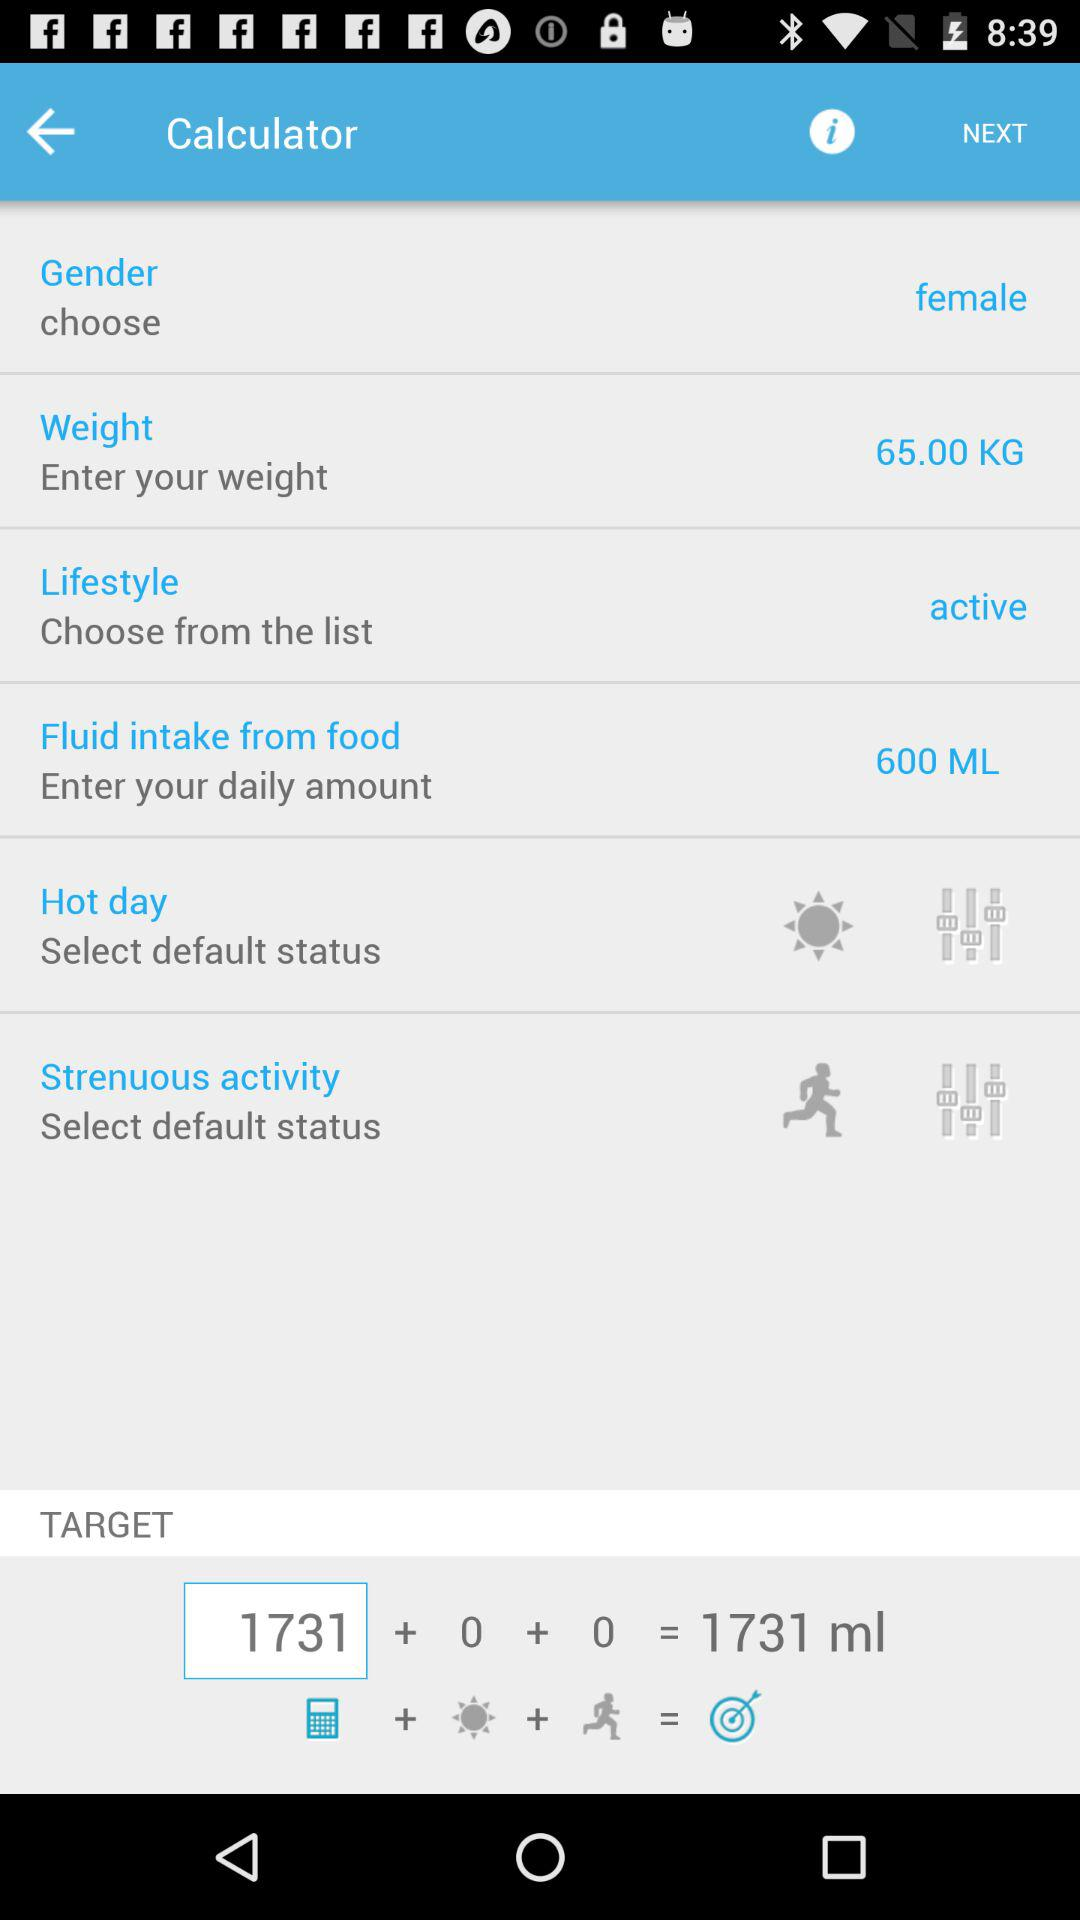How many ml of fluid are required based on the user's input?
Answer the question using a single word or phrase. 1731 ml 